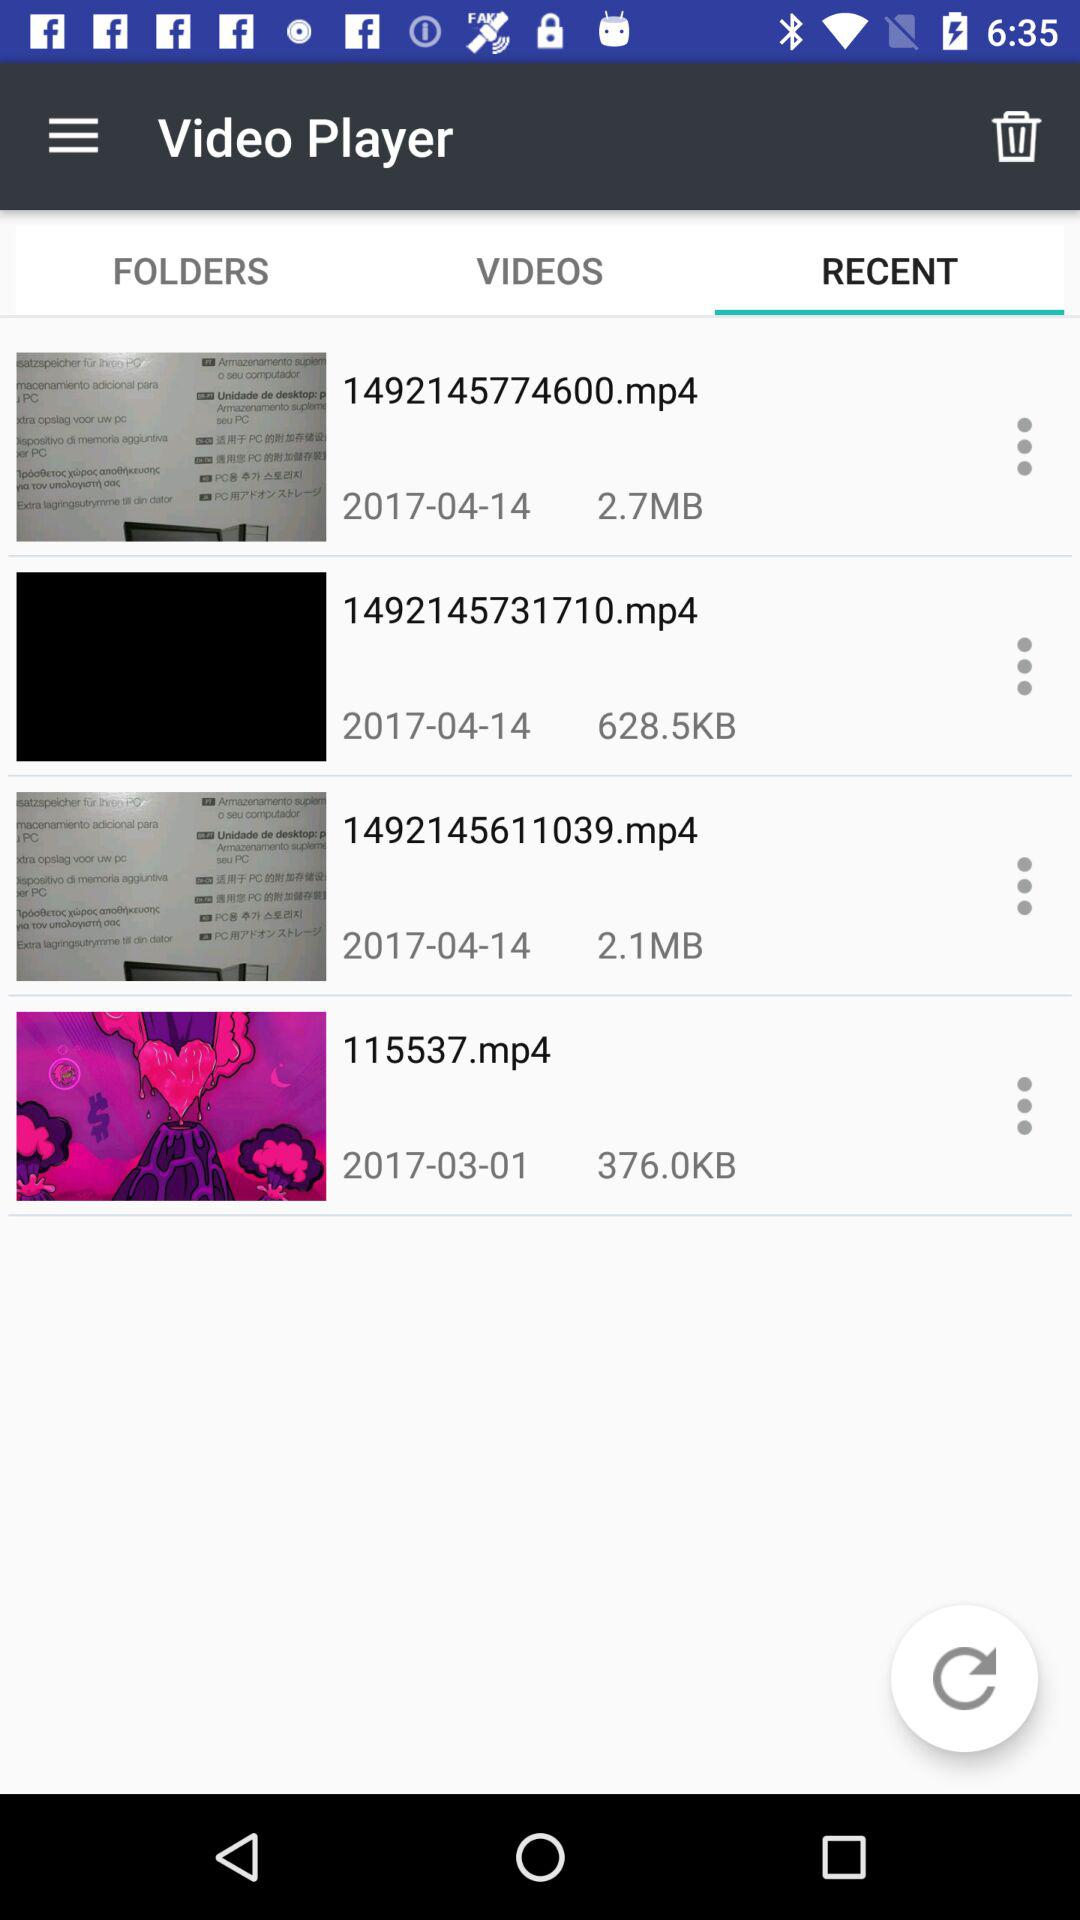How many files are there in the Recent tab?
Answer the question using a single word or phrase. 4 